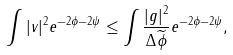<formula> <loc_0><loc_0><loc_500><loc_500>\int | v | ^ { 2 } e ^ { - 2 \phi - 2 \psi } \leq \int \frac { | g | ^ { 2 } } { \Delta \widetilde { \phi } } e ^ { - 2 \phi - 2 \psi } ,</formula> 